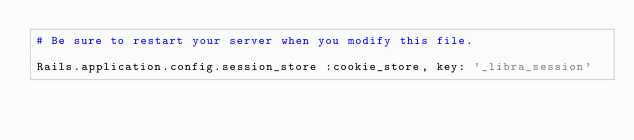<code> <loc_0><loc_0><loc_500><loc_500><_Ruby_># Be sure to restart your server when you modify this file.

Rails.application.config.session_store :cookie_store, key: '_libra_session'
</code> 